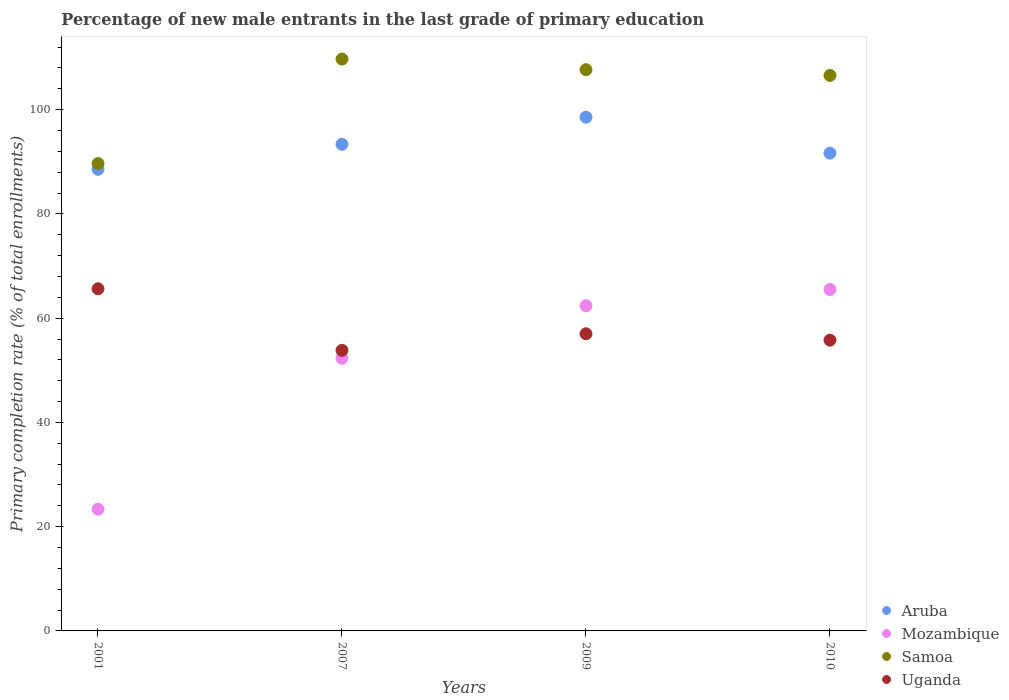How many different coloured dotlines are there?
Your answer should be compact. 4. Is the number of dotlines equal to the number of legend labels?
Make the answer very short. Yes. What is the percentage of new male entrants in Mozambique in 2009?
Make the answer very short. 62.38. Across all years, what is the maximum percentage of new male entrants in Samoa?
Give a very brief answer. 109.71. Across all years, what is the minimum percentage of new male entrants in Uganda?
Your response must be concise. 53.83. In which year was the percentage of new male entrants in Mozambique maximum?
Offer a very short reply. 2010. In which year was the percentage of new male entrants in Aruba minimum?
Keep it short and to the point. 2001. What is the total percentage of new male entrants in Aruba in the graph?
Make the answer very short. 372.15. What is the difference between the percentage of new male entrants in Aruba in 2007 and that in 2009?
Your answer should be compact. -5.2. What is the difference between the percentage of new male entrants in Aruba in 2001 and the percentage of new male entrants in Mozambique in 2009?
Offer a terse response. 26.19. What is the average percentage of new male entrants in Aruba per year?
Provide a succinct answer. 93.04. In the year 2010, what is the difference between the percentage of new male entrants in Aruba and percentage of new male entrants in Uganda?
Offer a terse response. 35.88. In how many years, is the percentage of new male entrants in Uganda greater than 92 %?
Your answer should be very brief. 0. What is the ratio of the percentage of new male entrants in Uganda in 2001 to that in 2010?
Offer a very short reply. 1.18. Is the difference between the percentage of new male entrants in Aruba in 2009 and 2010 greater than the difference between the percentage of new male entrants in Uganda in 2009 and 2010?
Your response must be concise. Yes. What is the difference between the highest and the second highest percentage of new male entrants in Mozambique?
Your answer should be very brief. 3.12. What is the difference between the highest and the lowest percentage of new male entrants in Samoa?
Your answer should be very brief. 20.05. Is the sum of the percentage of new male entrants in Uganda in 2001 and 2010 greater than the maximum percentage of new male entrants in Mozambique across all years?
Provide a succinct answer. Yes. Is it the case that in every year, the sum of the percentage of new male entrants in Aruba and percentage of new male entrants in Uganda  is greater than the percentage of new male entrants in Mozambique?
Your answer should be compact. Yes. Does the graph contain grids?
Provide a short and direct response. No. How are the legend labels stacked?
Offer a terse response. Vertical. What is the title of the graph?
Give a very brief answer. Percentage of new male entrants in the last grade of primary education. Does "Pakistan" appear as one of the legend labels in the graph?
Give a very brief answer. No. What is the label or title of the Y-axis?
Make the answer very short. Primary completion rate (% of total enrollments). What is the Primary completion rate (% of total enrollments) of Aruba in 2001?
Provide a short and direct response. 88.57. What is the Primary completion rate (% of total enrollments) in Mozambique in 2001?
Give a very brief answer. 23.35. What is the Primary completion rate (% of total enrollments) of Samoa in 2001?
Your answer should be compact. 89.66. What is the Primary completion rate (% of total enrollments) in Uganda in 2001?
Ensure brevity in your answer.  65.64. What is the Primary completion rate (% of total enrollments) in Aruba in 2007?
Provide a short and direct response. 93.36. What is the Primary completion rate (% of total enrollments) in Mozambique in 2007?
Offer a terse response. 52.31. What is the Primary completion rate (% of total enrollments) of Samoa in 2007?
Make the answer very short. 109.71. What is the Primary completion rate (% of total enrollments) in Uganda in 2007?
Your answer should be compact. 53.83. What is the Primary completion rate (% of total enrollments) of Aruba in 2009?
Offer a very short reply. 98.56. What is the Primary completion rate (% of total enrollments) in Mozambique in 2009?
Provide a succinct answer. 62.38. What is the Primary completion rate (% of total enrollments) in Samoa in 2009?
Give a very brief answer. 107.68. What is the Primary completion rate (% of total enrollments) in Uganda in 2009?
Give a very brief answer. 57.01. What is the Primary completion rate (% of total enrollments) in Aruba in 2010?
Provide a short and direct response. 91.67. What is the Primary completion rate (% of total enrollments) in Mozambique in 2010?
Provide a short and direct response. 65.5. What is the Primary completion rate (% of total enrollments) in Samoa in 2010?
Provide a short and direct response. 106.57. What is the Primary completion rate (% of total enrollments) in Uganda in 2010?
Keep it short and to the point. 55.79. Across all years, what is the maximum Primary completion rate (% of total enrollments) of Aruba?
Offer a terse response. 98.56. Across all years, what is the maximum Primary completion rate (% of total enrollments) of Mozambique?
Offer a very short reply. 65.5. Across all years, what is the maximum Primary completion rate (% of total enrollments) of Samoa?
Give a very brief answer. 109.71. Across all years, what is the maximum Primary completion rate (% of total enrollments) in Uganda?
Provide a succinct answer. 65.64. Across all years, what is the minimum Primary completion rate (% of total enrollments) of Aruba?
Make the answer very short. 88.57. Across all years, what is the minimum Primary completion rate (% of total enrollments) in Mozambique?
Provide a succinct answer. 23.35. Across all years, what is the minimum Primary completion rate (% of total enrollments) in Samoa?
Your answer should be very brief. 89.66. Across all years, what is the minimum Primary completion rate (% of total enrollments) in Uganda?
Offer a very short reply. 53.83. What is the total Primary completion rate (% of total enrollments) in Aruba in the graph?
Your answer should be very brief. 372.15. What is the total Primary completion rate (% of total enrollments) in Mozambique in the graph?
Make the answer very short. 203.54. What is the total Primary completion rate (% of total enrollments) of Samoa in the graph?
Keep it short and to the point. 413.62. What is the total Primary completion rate (% of total enrollments) in Uganda in the graph?
Offer a very short reply. 232.27. What is the difference between the Primary completion rate (% of total enrollments) of Aruba in 2001 and that in 2007?
Make the answer very short. -4.79. What is the difference between the Primary completion rate (% of total enrollments) in Mozambique in 2001 and that in 2007?
Ensure brevity in your answer.  -28.96. What is the difference between the Primary completion rate (% of total enrollments) in Samoa in 2001 and that in 2007?
Your answer should be compact. -20.05. What is the difference between the Primary completion rate (% of total enrollments) of Uganda in 2001 and that in 2007?
Offer a terse response. 11.81. What is the difference between the Primary completion rate (% of total enrollments) of Aruba in 2001 and that in 2009?
Give a very brief answer. -9.99. What is the difference between the Primary completion rate (% of total enrollments) of Mozambique in 2001 and that in 2009?
Your answer should be compact. -39.03. What is the difference between the Primary completion rate (% of total enrollments) in Samoa in 2001 and that in 2009?
Ensure brevity in your answer.  -18.01. What is the difference between the Primary completion rate (% of total enrollments) in Uganda in 2001 and that in 2009?
Offer a very short reply. 8.63. What is the difference between the Primary completion rate (% of total enrollments) in Aruba in 2001 and that in 2010?
Ensure brevity in your answer.  -3.1. What is the difference between the Primary completion rate (% of total enrollments) in Mozambique in 2001 and that in 2010?
Give a very brief answer. -42.15. What is the difference between the Primary completion rate (% of total enrollments) in Samoa in 2001 and that in 2010?
Offer a very short reply. -16.91. What is the difference between the Primary completion rate (% of total enrollments) of Uganda in 2001 and that in 2010?
Offer a very short reply. 9.86. What is the difference between the Primary completion rate (% of total enrollments) in Aruba in 2007 and that in 2009?
Your answer should be very brief. -5.2. What is the difference between the Primary completion rate (% of total enrollments) in Mozambique in 2007 and that in 2009?
Your answer should be very brief. -10.07. What is the difference between the Primary completion rate (% of total enrollments) in Samoa in 2007 and that in 2009?
Provide a short and direct response. 2.03. What is the difference between the Primary completion rate (% of total enrollments) of Uganda in 2007 and that in 2009?
Your answer should be compact. -3.18. What is the difference between the Primary completion rate (% of total enrollments) in Aruba in 2007 and that in 2010?
Provide a succinct answer. 1.69. What is the difference between the Primary completion rate (% of total enrollments) in Mozambique in 2007 and that in 2010?
Your answer should be compact. -13.19. What is the difference between the Primary completion rate (% of total enrollments) of Samoa in 2007 and that in 2010?
Your response must be concise. 3.14. What is the difference between the Primary completion rate (% of total enrollments) of Uganda in 2007 and that in 2010?
Your response must be concise. -1.96. What is the difference between the Primary completion rate (% of total enrollments) of Aruba in 2009 and that in 2010?
Ensure brevity in your answer.  6.9. What is the difference between the Primary completion rate (% of total enrollments) in Mozambique in 2009 and that in 2010?
Offer a very short reply. -3.12. What is the difference between the Primary completion rate (% of total enrollments) of Samoa in 2009 and that in 2010?
Your answer should be very brief. 1.1. What is the difference between the Primary completion rate (% of total enrollments) of Uganda in 2009 and that in 2010?
Give a very brief answer. 1.22. What is the difference between the Primary completion rate (% of total enrollments) of Aruba in 2001 and the Primary completion rate (% of total enrollments) of Mozambique in 2007?
Make the answer very short. 36.26. What is the difference between the Primary completion rate (% of total enrollments) in Aruba in 2001 and the Primary completion rate (% of total enrollments) in Samoa in 2007?
Make the answer very short. -21.14. What is the difference between the Primary completion rate (% of total enrollments) of Aruba in 2001 and the Primary completion rate (% of total enrollments) of Uganda in 2007?
Keep it short and to the point. 34.74. What is the difference between the Primary completion rate (% of total enrollments) in Mozambique in 2001 and the Primary completion rate (% of total enrollments) in Samoa in 2007?
Offer a very short reply. -86.36. What is the difference between the Primary completion rate (% of total enrollments) in Mozambique in 2001 and the Primary completion rate (% of total enrollments) in Uganda in 2007?
Give a very brief answer. -30.48. What is the difference between the Primary completion rate (% of total enrollments) of Samoa in 2001 and the Primary completion rate (% of total enrollments) of Uganda in 2007?
Make the answer very short. 35.83. What is the difference between the Primary completion rate (% of total enrollments) of Aruba in 2001 and the Primary completion rate (% of total enrollments) of Mozambique in 2009?
Make the answer very short. 26.19. What is the difference between the Primary completion rate (% of total enrollments) in Aruba in 2001 and the Primary completion rate (% of total enrollments) in Samoa in 2009?
Ensure brevity in your answer.  -19.11. What is the difference between the Primary completion rate (% of total enrollments) in Aruba in 2001 and the Primary completion rate (% of total enrollments) in Uganda in 2009?
Your answer should be very brief. 31.56. What is the difference between the Primary completion rate (% of total enrollments) of Mozambique in 2001 and the Primary completion rate (% of total enrollments) of Samoa in 2009?
Your response must be concise. -84.33. What is the difference between the Primary completion rate (% of total enrollments) of Mozambique in 2001 and the Primary completion rate (% of total enrollments) of Uganda in 2009?
Ensure brevity in your answer.  -33.66. What is the difference between the Primary completion rate (% of total enrollments) in Samoa in 2001 and the Primary completion rate (% of total enrollments) in Uganda in 2009?
Give a very brief answer. 32.65. What is the difference between the Primary completion rate (% of total enrollments) in Aruba in 2001 and the Primary completion rate (% of total enrollments) in Mozambique in 2010?
Keep it short and to the point. 23.07. What is the difference between the Primary completion rate (% of total enrollments) of Aruba in 2001 and the Primary completion rate (% of total enrollments) of Samoa in 2010?
Your response must be concise. -18.01. What is the difference between the Primary completion rate (% of total enrollments) of Aruba in 2001 and the Primary completion rate (% of total enrollments) of Uganda in 2010?
Offer a terse response. 32.78. What is the difference between the Primary completion rate (% of total enrollments) in Mozambique in 2001 and the Primary completion rate (% of total enrollments) in Samoa in 2010?
Provide a succinct answer. -83.22. What is the difference between the Primary completion rate (% of total enrollments) in Mozambique in 2001 and the Primary completion rate (% of total enrollments) in Uganda in 2010?
Ensure brevity in your answer.  -32.44. What is the difference between the Primary completion rate (% of total enrollments) of Samoa in 2001 and the Primary completion rate (% of total enrollments) of Uganda in 2010?
Provide a succinct answer. 33.88. What is the difference between the Primary completion rate (% of total enrollments) in Aruba in 2007 and the Primary completion rate (% of total enrollments) in Mozambique in 2009?
Ensure brevity in your answer.  30.98. What is the difference between the Primary completion rate (% of total enrollments) of Aruba in 2007 and the Primary completion rate (% of total enrollments) of Samoa in 2009?
Offer a very short reply. -14.32. What is the difference between the Primary completion rate (% of total enrollments) in Aruba in 2007 and the Primary completion rate (% of total enrollments) in Uganda in 2009?
Make the answer very short. 36.35. What is the difference between the Primary completion rate (% of total enrollments) in Mozambique in 2007 and the Primary completion rate (% of total enrollments) in Samoa in 2009?
Give a very brief answer. -55.36. What is the difference between the Primary completion rate (% of total enrollments) in Mozambique in 2007 and the Primary completion rate (% of total enrollments) in Uganda in 2009?
Give a very brief answer. -4.7. What is the difference between the Primary completion rate (% of total enrollments) in Samoa in 2007 and the Primary completion rate (% of total enrollments) in Uganda in 2009?
Your answer should be very brief. 52.7. What is the difference between the Primary completion rate (% of total enrollments) of Aruba in 2007 and the Primary completion rate (% of total enrollments) of Mozambique in 2010?
Your answer should be very brief. 27.86. What is the difference between the Primary completion rate (% of total enrollments) in Aruba in 2007 and the Primary completion rate (% of total enrollments) in Samoa in 2010?
Provide a short and direct response. -13.21. What is the difference between the Primary completion rate (% of total enrollments) of Aruba in 2007 and the Primary completion rate (% of total enrollments) of Uganda in 2010?
Provide a succinct answer. 37.57. What is the difference between the Primary completion rate (% of total enrollments) of Mozambique in 2007 and the Primary completion rate (% of total enrollments) of Samoa in 2010?
Give a very brief answer. -54.26. What is the difference between the Primary completion rate (% of total enrollments) in Mozambique in 2007 and the Primary completion rate (% of total enrollments) in Uganda in 2010?
Your answer should be very brief. -3.48. What is the difference between the Primary completion rate (% of total enrollments) in Samoa in 2007 and the Primary completion rate (% of total enrollments) in Uganda in 2010?
Keep it short and to the point. 53.92. What is the difference between the Primary completion rate (% of total enrollments) of Aruba in 2009 and the Primary completion rate (% of total enrollments) of Mozambique in 2010?
Your response must be concise. 33.06. What is the difference between the Primary completion rate (% of total enrollments) in Aruba in 2009 and the Primary completion rate (% of total enrollments) in Samoa in 2010?
Offer a terse response. -8.01. What is the difference between the Primary completion rate (% of total enrollments) of Aruba in 2009 and the Primary completion rate (% of total enrollments) of Uganda in 2010?
Offer a very short reply. 42.78. What is the difference between the Primary completion rate (% of total enrollments) of Mozambique in 2009 and the Primary completion rate (% of total enrollments) of Samoa in 2010?
Offer a terse response. -44.2. What is the difference between the Primary completion rate (% of total enrollments) of Mozambique in 2009 and the Primary completion rate (% of total enrollments) of Uganda in 2010?
Give a very brief answer. 6.59. What is the difference between the Primary completion rate (% of total enrollments) of Samoa in 2009 and the Primary completion rate (% of total enrollments) of Uganda in 2010?
Offer a very short reply. 51.89. What is the average Primary completion rate (% of total enrollments) of Aruba per year?
Give a very brief answer. 93.04. What is the average Primary completion rate (% of total enrollments) of Mozambique per year?
Ensure brevity in your answer.  50.88. What is the average Primary completion rate (% of total enrollments) in Samoa per year?
Your answer should be very brief. 103.41. What is the average Primary completion rate (% of total enrollments) of Uganda per year?
Your answer should be very brief. 58.07. In the year 2001, what is the difference between the Primary completion rate (% of total enrollments) in Aruba and Primary completion rate (% of total enrollments) in Mozambique?
Provide a short and direct response. 65.22. In the year 2001, what is the difference between the Primary completion rate (% of total enrollments) of Aruba and Primary completion rate (% of total enrollments) of Samoa?
Your answer should be very brief. -1.1. In the year 2001, what is the difference between the Primary completion rate (% of total enrollments) of Aruba and Primary completion rate (% of total enrollments) of Uganda?
Provide a short and direct response. 22.92. In the year 2001, what is the difference between the Primary completion rate (% of total enrollments) of Mozambique and Primary completion rate (% of total enrollments) of Samoa?
Your answer should be compact. -66.31. In the year 2001, what is the difference between the Primary completion rate (% of total enrollments) of Mozambique and Primary completion rate (% of total enrollments) of Uganda?
Provide a succinct answer. -42.29. In the year 2001, what is the difference between the Primary completion rate (% of total enrollments) in Samoa and Primary completion rate (% of total enrollments) in Uganda?
Ensure brevity in your answer.  24.02. In the year 2007, what is the difference between the Primary completion rate (% of total enrollments) of Aruba and Primary completion rate (% of total enrollments) of Mozambique?
Your response must be concise. 41.05. In the year 2007, what is the difference between the Primary completion rate (% of total enrollments) of Aruba and Primary completion rate (% of total enrollments) of Samoa?
Offer a terse response. -16.35. In the year 2007, what is the difference between the Primary completion rate (% of total enrollments) in Aruba and Primary completion rate (% of total enrollments) in Uganda?
Offer a terse response. 39.53. In the year 2007, what is the difference between the Primary completion rate (% of total enrollments) in Mozambique and Primary completion rate (% of total enrollments) in Samoa?
Your answer should be compact. -57.4. In the year 2007, what is the difference between the Primary completion rate (% of total enrollments) in Mozambique and Primary completion rate (% of total enrollments) in Uganda?
Keep it short and to the point. -1.52. In the year 2007, what is the difference between the Primary completion rate (% of total enrollments) of Samoa and Primary completion rate (% of total enrollments) of Uganda?
Your answer should be very brief. 55.88. In the year 2009, what is the difference between the Primary completion rate (% of total enrollments) of Aruba and Primary completion rate (% of total enrollments) of Mozambique?
Offer a terse response. 36.18. In the year 2009, what is the difference between the Primary completion rate (% of total enrollments) in Aruba and Primary completion rate (% of total enrollments) in Samoa?
Your answer should be compact. -9.11. In the year 2009, what is the difference between the Primary completion rate (% of total enrollments) of Aruba and Primary completion rate (% of total enrollments) of Uganda?
Offer a very short reply. 41.55. In the year 2009, what is the difference between the Primary completion rate (% of total enrollments) of Mozambique and Primary completion rate (% of total enrollments) of Samoa?
Provide a short and direct response. -45.3. In the year 2009, what is the difference between the Primary completion rate (% of total enrollments) in Mozambique and Primary completion rate (% of total enrollments) in Uganda?
Provide a succinct answer. 5.37. In the year 2009, what is the difference between the Primary completion rate (% of total enrollments) in Samoa and Primary completion rate (% of total enrollments) in Uganda?
Ensure brevity in your answer.  50.67. In the year 2010, what is the difference between the Primary completion rate (% of total enrollments) of Aruba and Primary completion rate (% of total enrollments) of Mozambique?
Your answer should be compact. 26.17. In the year 2010, what is the difference between the Primary completion rate (% of total enrollments) of Aruba and Primary completion rate (% of total enrollments) of Samoa?
Provide a short and direct response. -14.91. In the year 2010, what is the difference between the Primary completion rate (% of total enrollments) in Aruba and Primary completion rate (% of total enrollments) in Uganda?
Keep it short and to the point. 35.88. In the year 2010, what is the difference between the Primary completion rate (% of total enrollments) in Mozambique and Primary completion rate (% of total enrollments) in Samoa?
Provide a succinct answer. -41.07. In the year 2010, what is the difference between the Primary completion rate (% of total enrollments) in Mozambique and Primary completion rate (% of total enrollments) in Uganda?
Provide a succinct answer. 9.71. In the year 2010, what is the difference between the Primary completion rate (% of total enrollments) of Samoa and Primary completion rate (% of total enrollments) of Uganda?
Offer a terse response. 50.79. What is the ratio of the Primary completion rate (% of total enrollments) in Aruba in 2001 to that in 2007?
Your answer should be compact. 0.95. What is the ratio of the Primary completion rate (% of total enrollments) of Mozambique in 2001 to that in 2007?
Ensure brevity in your answer.  0.45. What is the ratio of the Primary completion rate (% of total enrollments) of Samoa in 2001 to that in 2007?
Your answer should be compact. 0.82. What is the ratio of the Primary completion rate (% of total enrollments) in Uganda in 2001 to that in 2007?
Offer a terse response. 1.22. What is the ratio of the Primary completion rate (% of total enrollments) in Aruba in 2001 to that in 2009?
Offer a terse response. 0.9. What is the ratio of the Primary completion rate (% of total enrollments) in Mozambique in 2001 to that in 2009?
Offer a terse response. 0.37. What is the ratio of the Primary completion rate (% of total enrollments) of Samoa in 2001 to that in 2009?
Provide a short and direct response. 0.83. What is the ratio of the Primary completion rate (% of total enrollments) of Uganda in 2001 to that in 2009?
Your response must be concise. 1.15. What is the ratio of the Primary completion rate (% of total enrollments) of Aruba in 2001 to that in 2010?
Offer a terse response. 0.97. What is the ratio of the Primary completion rate (% of total enrollments) in Mozambique in 2001 to that in 2010?
Your answer should be compact. 0.36. What is the ratio of the Primary completion rate (% of total enrollments) of Samoa in 2001 to that in 2010?
Your response must be concise. 0.84. What is the ratio of the Primary completion rate (% of total enrollments) in Uganda in 2001 to that in 2010?
Provide a short and direct response. 1.18. What is the ratio of the Primary completion rate (% of total enrollments) of Aruba in 2007 to that in 2009?
Offer a very short reply. 0.95. What is the ratio of the Primary completion rate (% of total enrollments) in Mozambique in 2007 to that in 2009?
Your response must be concise. 0.84. What is the ratio of the Primary completion rate (% of total enrollments) of Samoa in 2007 to that in 2009?
Provide a short and direct response. 1.02. What is the ratio of the Primary completion rate (% of total enrollments) of Uganda in 2007 to that in 2009?
Give a very brief answer. 0.94. What is the ratio of the Primary completion rate (% of total enrollments) in Aruba in 2007 to that in 2010?
Ensure brevity in your answer.  1.02. What is the ratio of the Primary completion rate (% of total enrollments) of Mozambique in 2007 to that in 2010?
Offer a very short reply. 0.8. What is the ratio of the Primary completion rate (% of total enrollments) of Samoa in 2007 to that in 2010?
Your answer should be compact. 1.03. What is the ratio of the Primary completion rate (% of total enrollments) of Uganda in 2007 to that in 2010?
Provide a succinct answer. 0.96. What is the ratio of the Primary completion rate (% of total enrollments) in Aruba in 2009 to that in 2010?
Make the answer very short. 1.08. What is the ratio of the Primary completion rate (% of total enrollments) in Mozambique in 2009 to that in 2010?
Provide a succinct answer. 0.95. What is the ratio of the Primary completion rate (% of total enrollments) of Samoa in 2009 to that in 2010?
Your answer should be very brief. 1.01. What is the ratio of the Primary completion rate (% of total enrollments) of Uganda in 2009 to that in 2010?
Offer a very short reply. 1.02. What is the difference between the highest and the second highest Primary completion rate (% of total enrollments) of Aruba?
Ensure brevity in your answer.  5.2. What is the difference between the highest and the second highest Primary completion rate (% of total enrollments) of Mozambique?
Keep it short and to the point. 3.12. What is the difference between the highest and the second highest Primary completion rate (% of total enrollments) of Samoa?
Make the answer very short. 2.03. What is the difference between the highest and the second highest Primary completion rate (% of total enrollments) of Uganda?
Provide a short and direct response. 8.63. What is the difference between the highest and the lowest Primary completion rate (% of total enrollments) of Aruba?
Make the answer very short. 9.99. What is the difference between the highest and the lowest Primary completion rate (% of total enrollments) of Mozambique?
Your answer should be compact. 42.15. What is the difference between the highest and the lowest Primary completion rate (% of total enrollments) of Samoa?
Keep it short and to the point. 20.05. What is the difference between the highest and the lowest Primary completion rate (% of total enrollments) of Uganda?
Provide a succinct answer. 11.81. 